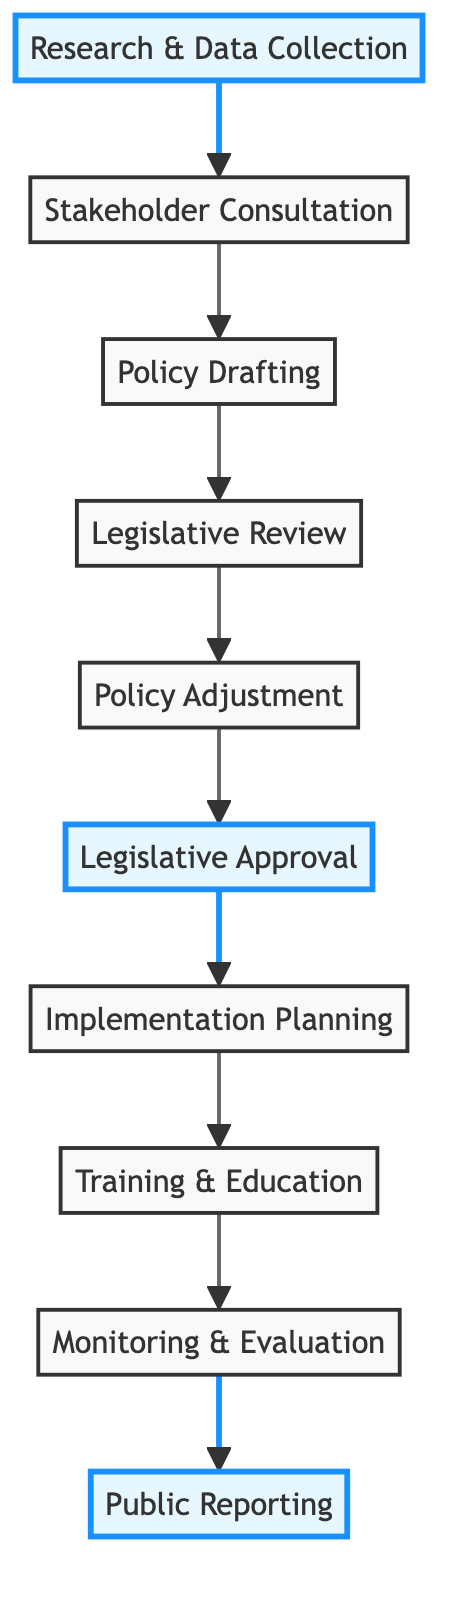What is the first step in the flowchart? The first step is labeled as "Research & Data Collection," which is the initial action taken to gather information on animal farming practices and welfare issues.
Answer: Research & Data Collection How many steps are in the flowchart? By counting each node from "Research & Data Collection" to "Public Reporting," there are a total of 10 distinct steps in the flowchart.
Answer: 10 What comes after "Legislative Approval"? Following "Legislative Approval," the next step is "Implementation Planning," indicating the process of rolling out the new regulations after approval.
Answer: Implementation Planning Which steps are highlighted in the diagram? The highlighted steps are "Research & Data Collection," "Legislative Approval," and "Public Reporting," indicating key phases in the overall process.
Answer: Research & Data Collection, Legislative Approval, Public Reporting What is the purpose of "Monitoring & Evaluation"? The purpose of "Monitoring & Evaluation" is to set up systems to monitor compliance and gather data on the impacts of the new regulations for potential adjustments.
Answer: To monitor compliance and evaluate impacts What is the relationship between "Policy Drafting" and "Legislative Review"? "Policy Drafting" directly leads to "Legislative Review," indicating that the drafted policy is reviewed by legal experts and committees to ensure compliance with laws.
Answer: Policy Drafting leads to Legislative Review Which step involves engagement with various stakeholders? The step that involves engagement with various stakeholders is "Stakeholder Consultation," where input is gathered from farmers, animal welfare organizations, and others.
Answer: Stakeholder Consultation What happens after the "Policy Adjustment" step? After "Policy Adjustment," the next step is "Legislative Approval," where efforts are made to advocate for the adjusted policy and secure necessary votes.
Answer: Legislative Approval What is the goal of "Training & Education"? The goal of "Training & Education" is to provide training and resources for farmers and enforcement personnel to ensure compliance with new regulations.
Answer: To provide training and resources for compliance 